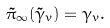Convert formula to latex. <formula><loc_0><loc_0><loc_500><loc_500>\tilde { \pi } _ { \infty } ( \tilde { \gamma } _ { v } ) = \gamma _ { v } .</formula> 